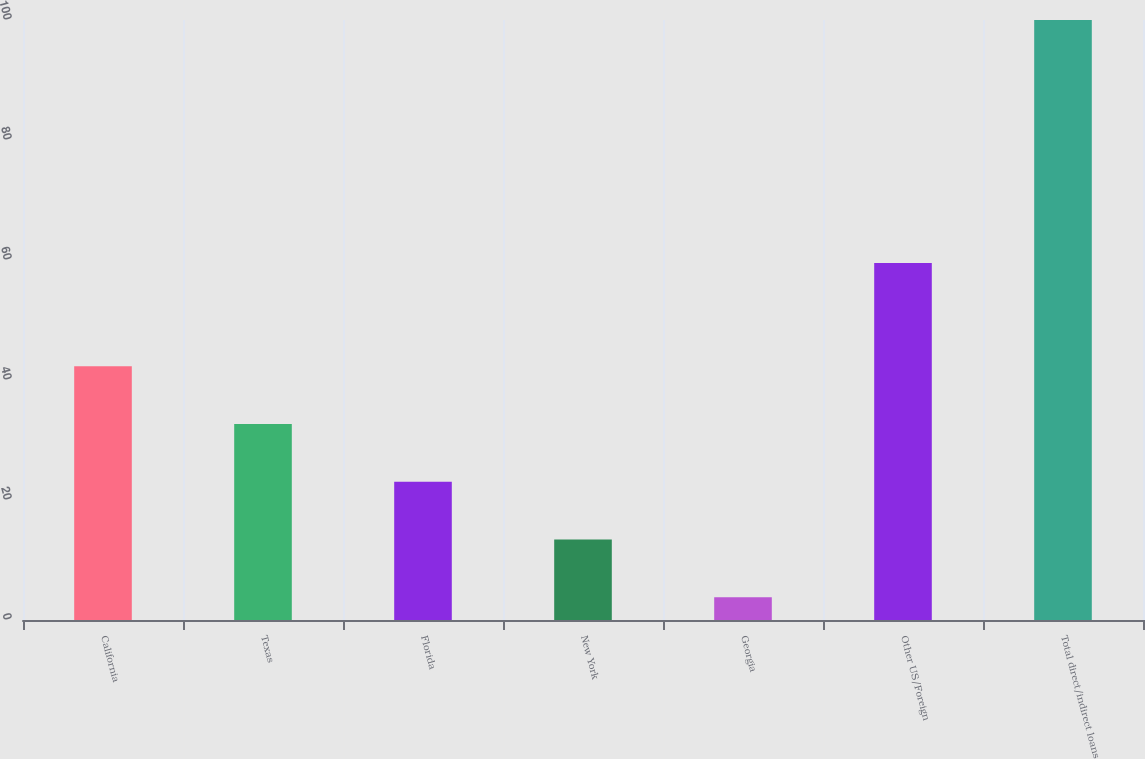Convert chart. <chart><loc_0><loc_0><loc_500><loc_500><bar_chart><fcel>California<fcel>Texas<fcel>Florida<fcel>New York<fcel>Georgia<fcel>Other US/Foreign<fcel>Total direct/indirect loans<nl><fcel>42.28<fcel>32.66<fcel>23.04<fcel>13.42<fcel>3.8<fcel>59.5<fcel>100<nl></chart> 